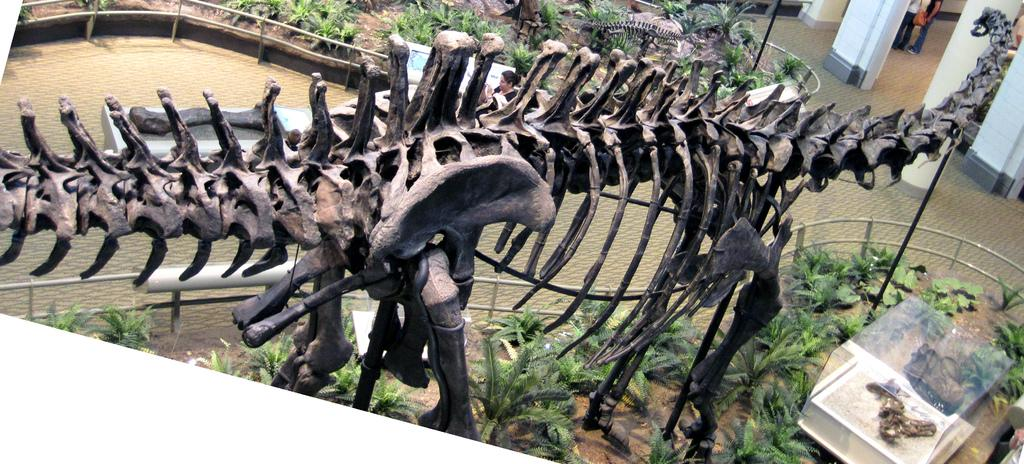What is the main subject of the image? The main subject of the image is a skeleton of an animal. What else can be seen in the image besides the animal skeleton? There are plants, railing, pillars, and people visible in the image. Can you describe the plants in the image? The plants in the image are not specified, but they are present. What architectural features are visible in the image? The railing and pillars are visible architectural features in the image. What type of cheese is being used to create the effect of the skeleton in the image? There is no cheese present in the image, and the skeleton is not an effect created by cheese. 